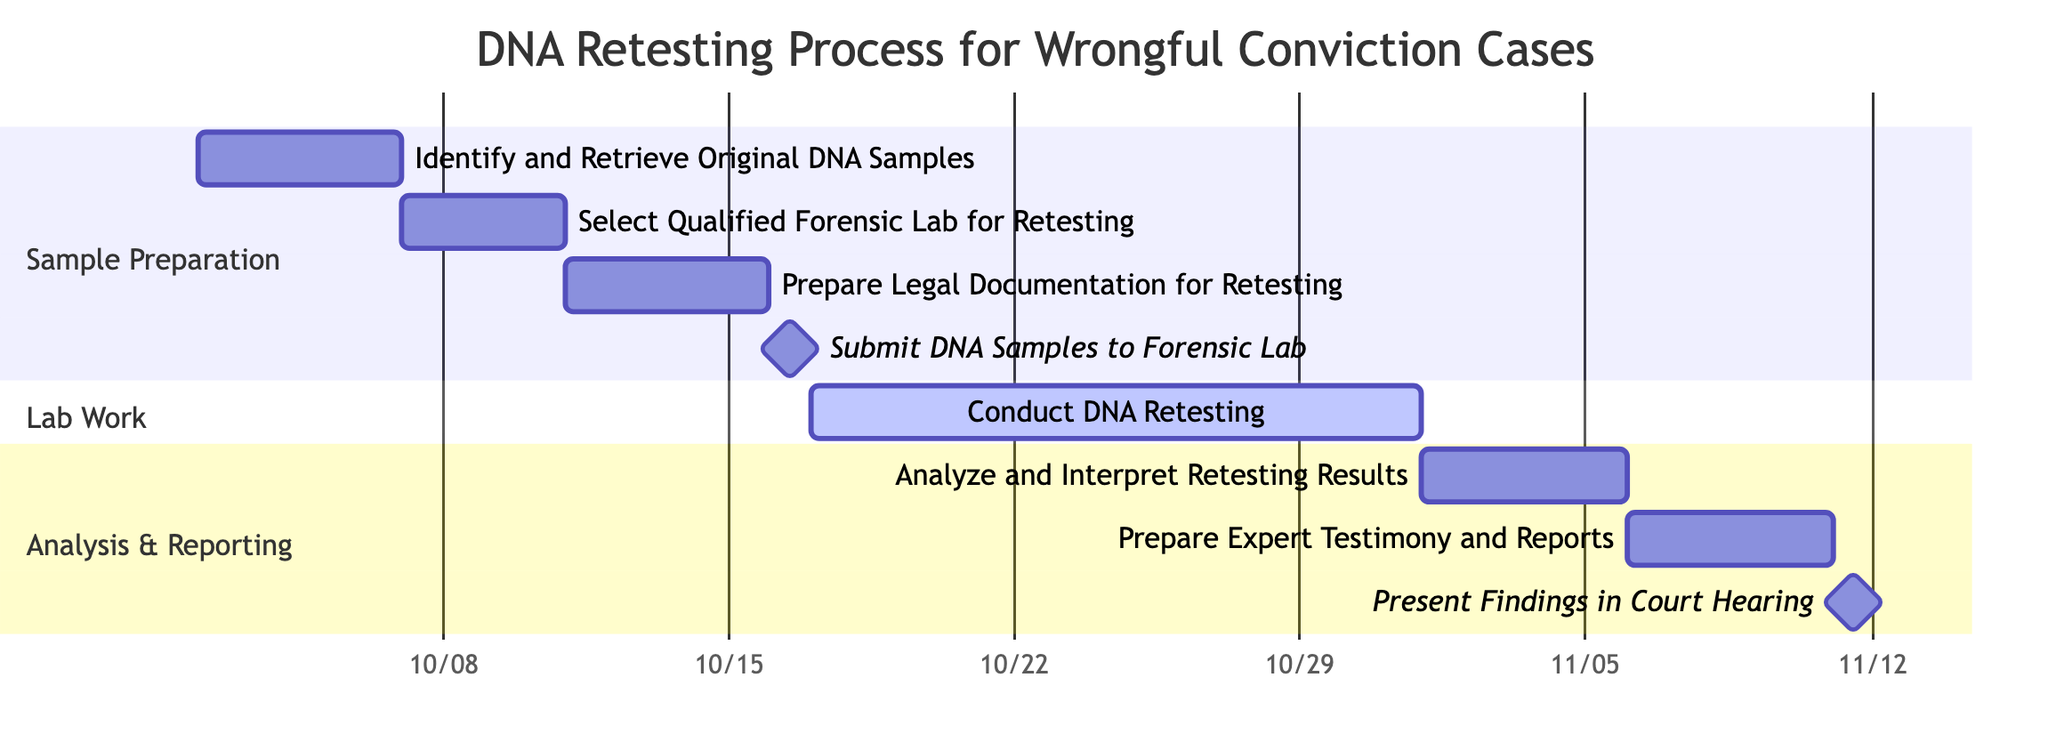What is the total number of tasks in the Gantt chart? The Gantt chart lists eight tasks in total, which include identifying and retrieving DNA samples, selecting a forensic lab, preparing legal documentation, submitting samples, conducting retesting, analyzing results, preparing expert testimony, and presenting findings.
Answer: 8 Which task starts on October 11, 2023? The task "Prepare Legal Documentation for Retesting" begins on October 11, 2023, as indicated by its start date in the Gantt chart.
Answer: Prepare Legal Documentation for Retesting What is the duration of the "Conduct DNA Retesting" task? The "Conduct DNA Retesting" task starts on October 17, 2023, and ends on October 31, 2023. The duration can be calculated as the difference between the end and start dates, which is 15 days.
Answer: 15 days How many tasks are scheduled before the "Submit DNA Samples to Forensic Lab" milestone? The tasks before the "Submit DNA Samples to Forensic Lab" milestone are "Identify and Retrieve Original DNA Samples," "Select Qualified Forensic Lab for Retesting," and "Prepare Legal Documentation for Retesting," making a total of three tasks.
Answer: 3 On which date is the "Present Findings in Court Hearing" milestone scheduled? The milestone for "Present Findings in Court Hearing" is scheduled for November 11, 2023, as shown in the end date associated with this task in the Gantt chart.
Answer: November 11, 2023 What task occurs immediately after the "Submit DNA Samples to Forensic Lab"? The task that immediately follows the "Submit DNA Samples to Forensic Lab" milestone is "Conduct DNA Retesting," which starts on October 17, 2023, right after the submission.
Answer: Conduct DNA Retesting Which section of the Gantt chart contains the task "Analyze and Interpret Retesting Results"? The task "Analyze and Interpret Retesting Results" is located in the "Analysis & Reporting" section of the Gantt chart, as identified by the section headers in the diagram.
Answer: Analysis & Reporting How long does the entire retesting process take from start to finish? The entire retesting process spans from October 2, 2023, the start date of the first task, to November 11, 2023, the date of the last milestone. Calculating the duration gives us 40 days in total.
Answer: 40 days 